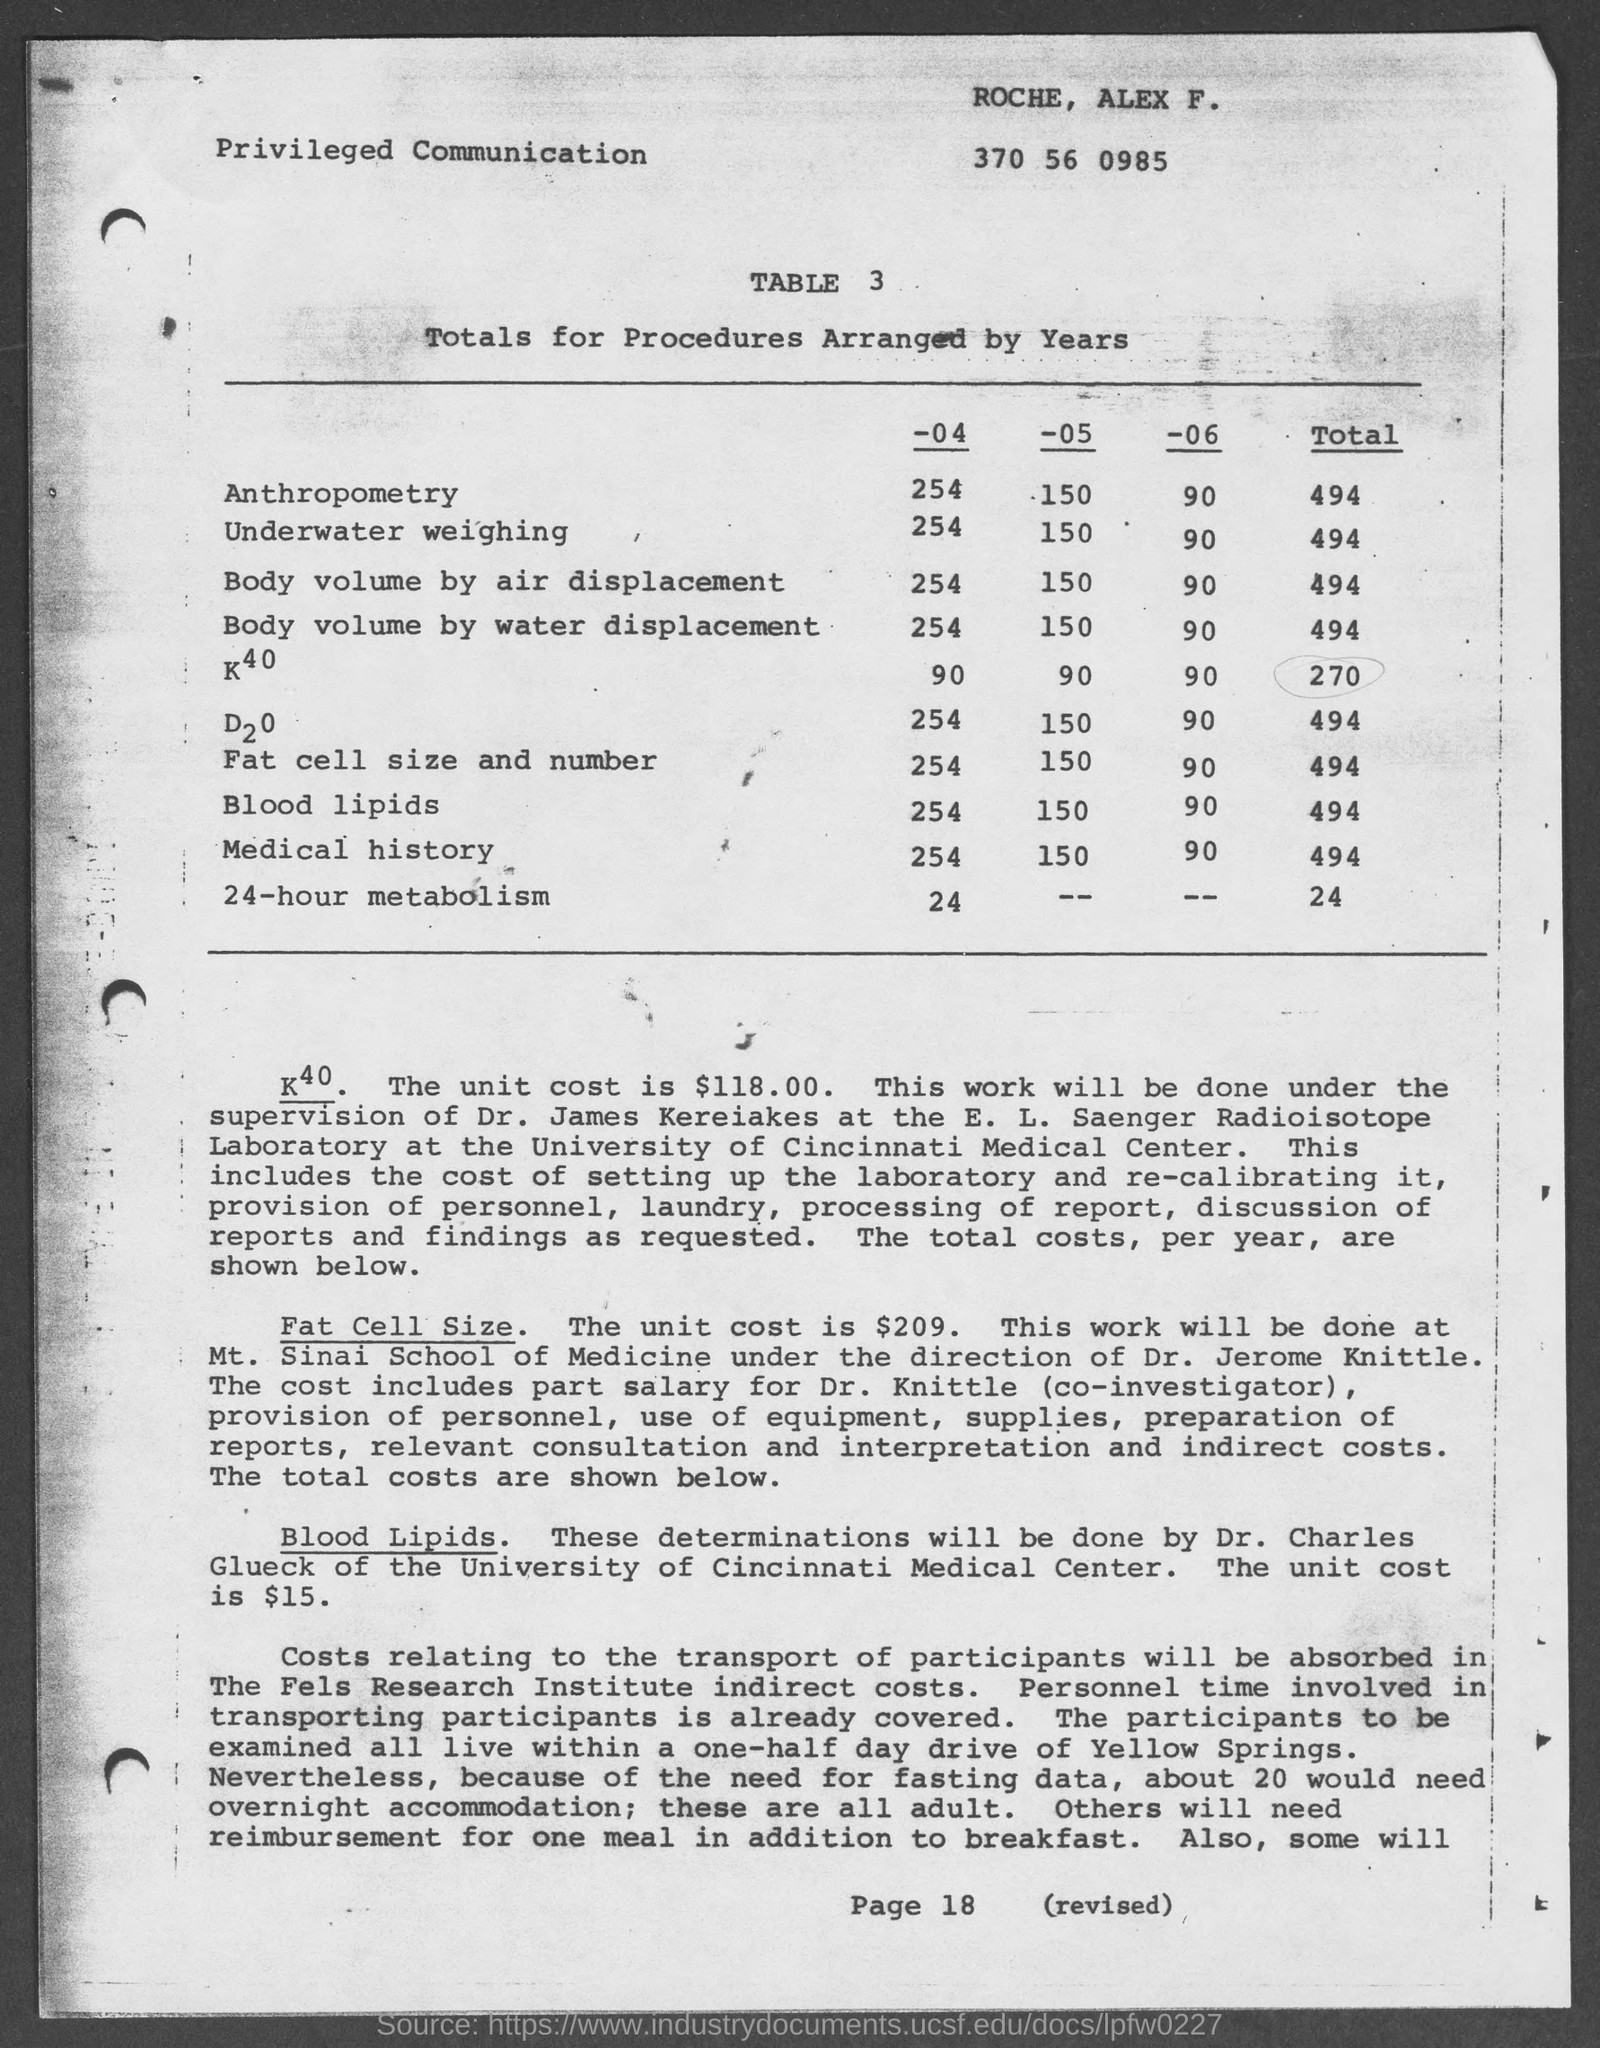What is the total value of anthropometry ?
Provide a succinct answer. 494. What is the total value of underwater weighing ?
Your answer should be very brief. 494. What is the total value of 24- hour metabolism ?
Offer a terse response. 24. What is the total value of body volume by air displacement ?
Ensure brevity in your answer.  494. What is the total value of body volume by water displacement ?
Provide a short and direct response. 494. 